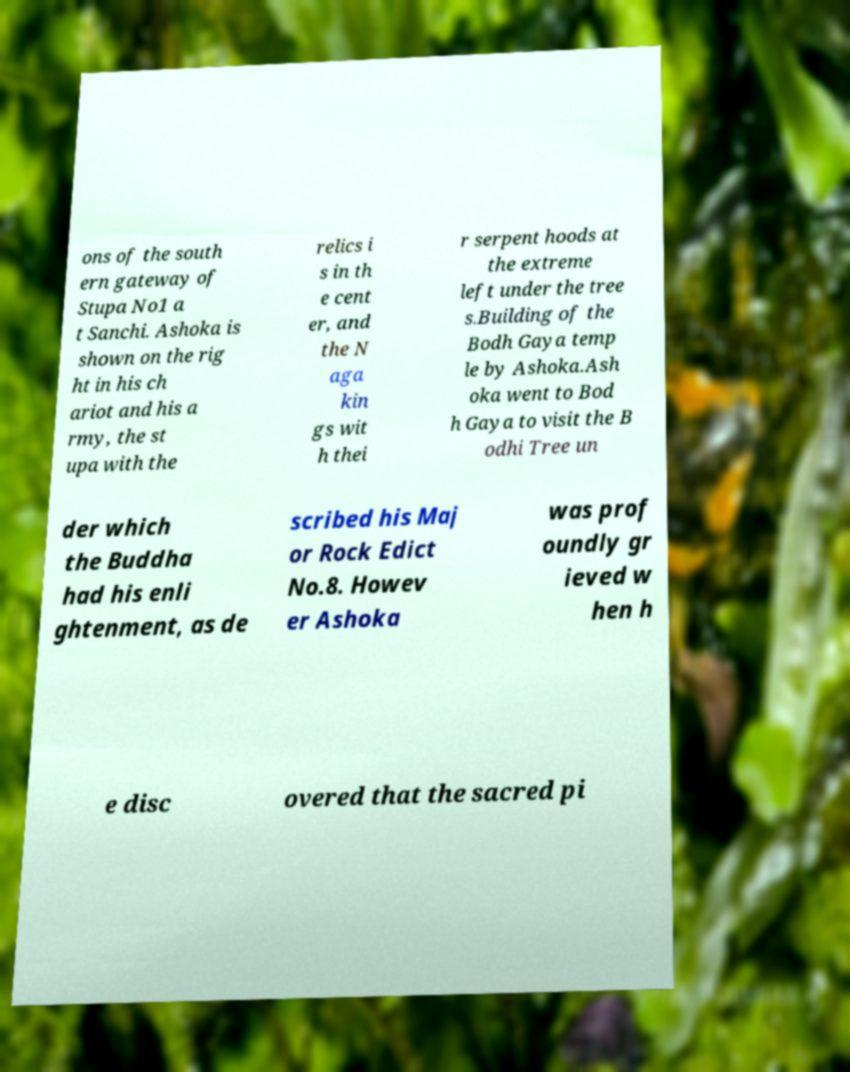I need the written content from this picture converted into text. Can you do that? ons of the south ern gateway of Stupa No1 a t Sanchi. Ashoka is shown on the rig ht in his ch ariot and his a rmy, the st upa with the relics i s in th e cent er, and the N aga kin gs wit h thei r serpent hoods at the extreme left under the tree s.Building of the Bodh Gaya temp le by Ashoka.Ash oka went to Bod h Gaya to visit the B odhi Tree un der which the Buddha had his enli ghtenment, as de scribed his Maj or Rock Edict No.8. Howev er Ashoka was prof oundly gr ieved w hen h e disc overed that the sacred pi 